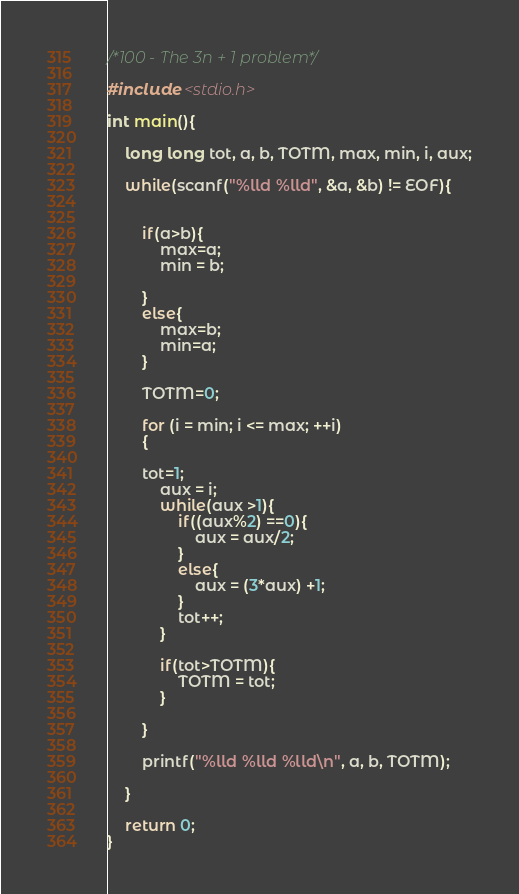Convert code to text. <code><loc_0><loc_0><loc_500><loc_500><_C_>/*100 - The 3n + 1 problem*/

#include <stdio.h>

int main(){
	
	long long tot, a, b, TOTM, max, min, i, aux;

	while(scanf("%lld %lld", &a, &b) != EOF){


		if(a>b){
			max=a;
			min = b;

		}
		else{
			max=b;
			min=a;
		}

	    TOTM=0;

		for (i = min; i <= max; ++i)
		{
		    	
		tot=1;
			aux = i;
			while(aux >1){
				if((aux%2) ==0){
					aux = aux/2;
				}
				else{
					aux = (3*aux) +1;
				}
				tot++;
			}

			if(tot>TOTM){
				TOTM = tot;
			}

		}

		printf("%lld %lld %lld\n", a, b, TOTM);

	}

	return 0;
}</code> 